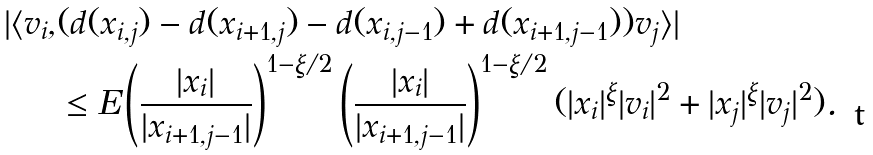<formula> <loc_0><loc_0><loc_500><loc_500>| \langle v _ { i } , & ( d ( x _ { i , j } ) - d ( x _ { i + 1 , j } ) - d ( x _ { i , j - 1 } ) + d ( x _ { i + 1 , j - 1 } ) ) v _ { j } \rangle | \\ & \leq E \left ( \frac { | x _ { i } | } { | x _ { i + 1 , j - 1 } | } \right ) ^ { 1 - \xi / 2 } \left ( \frac { | x _ { i } | } { | x _ { i + 1 , j - 1 } | } \right ) ^ { 1 - \xi / 2 } ( | x _ { i } | ^ { \xi } | v _ { i } | ^ { 2 } + | x _ { j } | ^ { \xi } | v _ { j } | ^ { 2 } ) .</formula> 